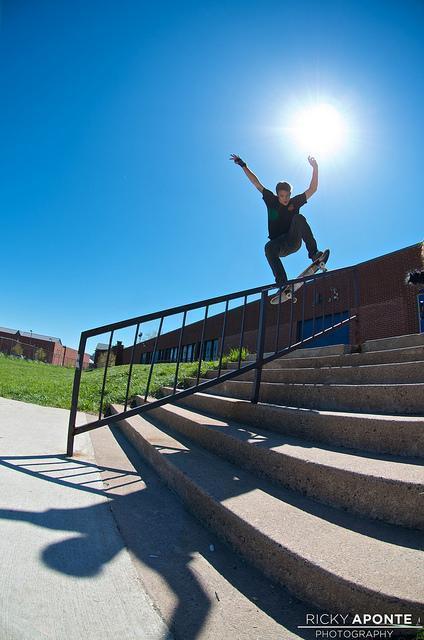How many cargo trucks do you see?
Give a very brief answer. 0. 